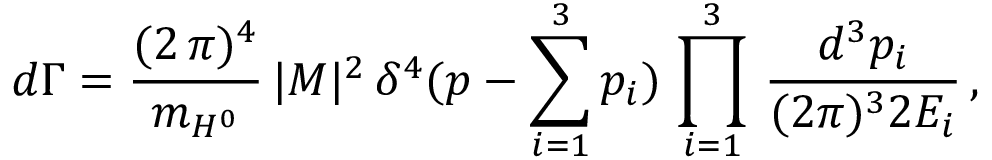Convert formula to latex. <formula><loc_0><loc_0><loc_500><loc_500>d \Gamma = \frac { ( 2 \, \pi ) ^ { 4 } } { m _ { H ^ { 0 } } } \, | M | ^ { 2 } \, \delta ^ { 4 } ( p - \sum _ { i = 1 } ^ { 3 } p _ { i } ) \, \prod _ { i = 1 } ^ { 3 } \, \frac { d ^ { 3 } p _ { i } } { ( 2 \pi ) ^ { 3 } 2 E _ { i } } \, ,</formula> 